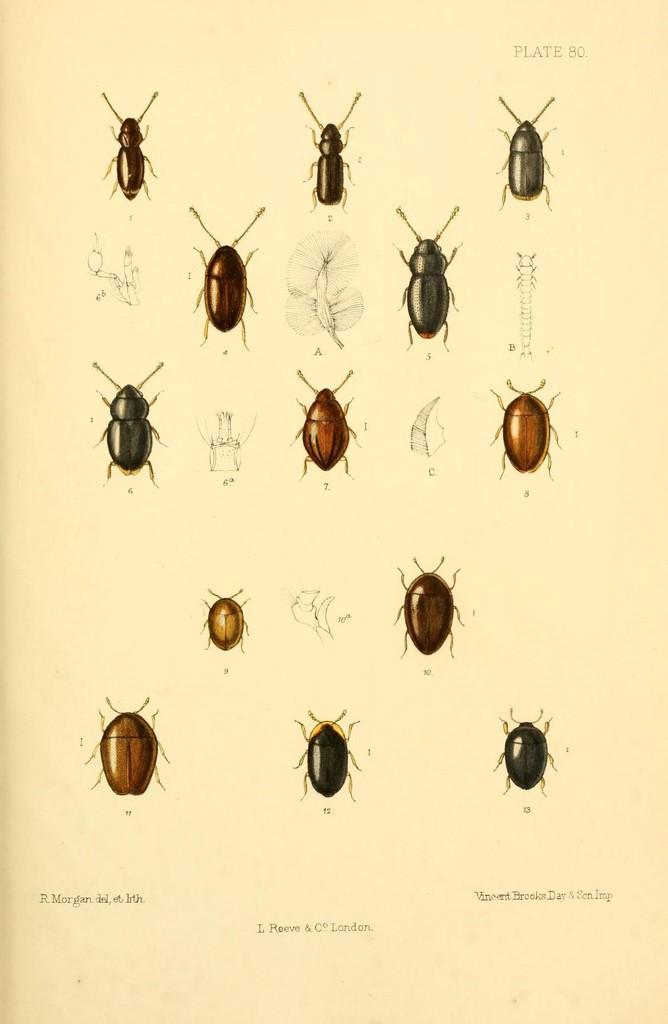What type of creatures can be seen in the image? There are insects depicted in the image. Where can text be found in the image? Text can be found on the top right and the bottom of the image. What type of bean is being cooked by the mother in the image? There is no bean or mother present in the image; it features insects and text. What type of monkey can be seen interacting with the insects in the image? There is no monkey present in the image; it only features insects and text. 